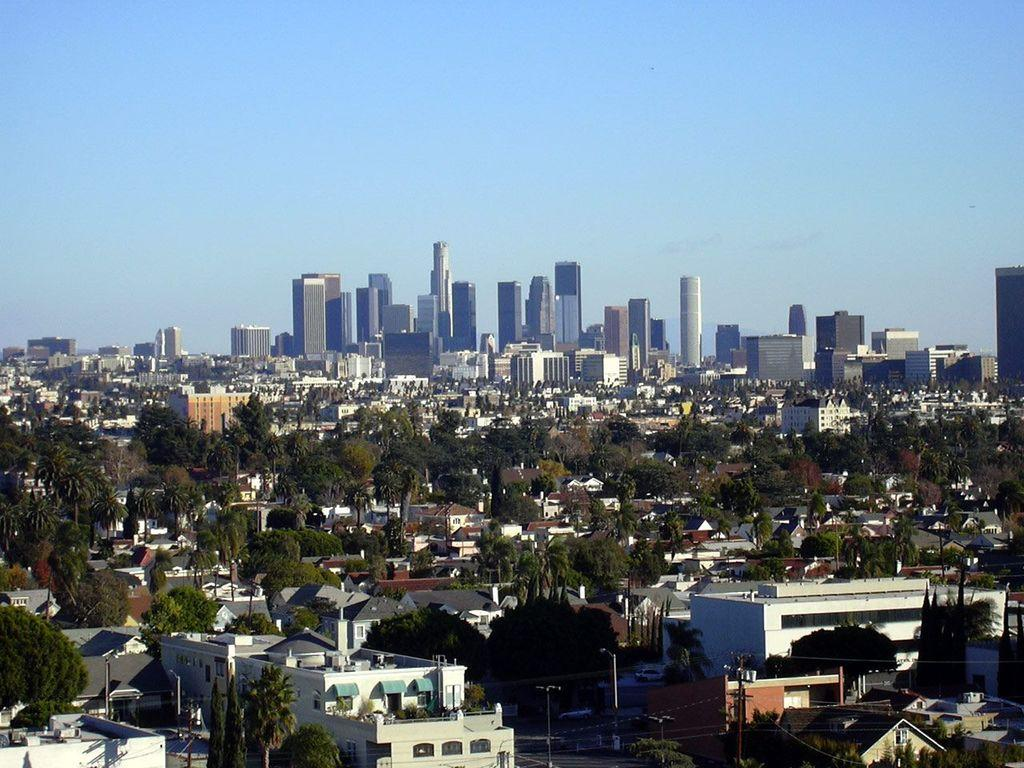What type of natural elements can be seen in the image? There are trees in the image. What type of man-made structures are present in the image? There are buildings in the image. What type of lighting is present in the image? There are street lamps in the image. What is visible at the top of the image? The sky is visible at the top of the image. What word is written on the tree trunk in the image? There is no word written on the tree trunk in the image; only trees, buildings, street lamps, and the sky are visible. How does the cork help to secure the buildings in the image? There is no cork present in the image, and the buildings are not secured by any cork. 